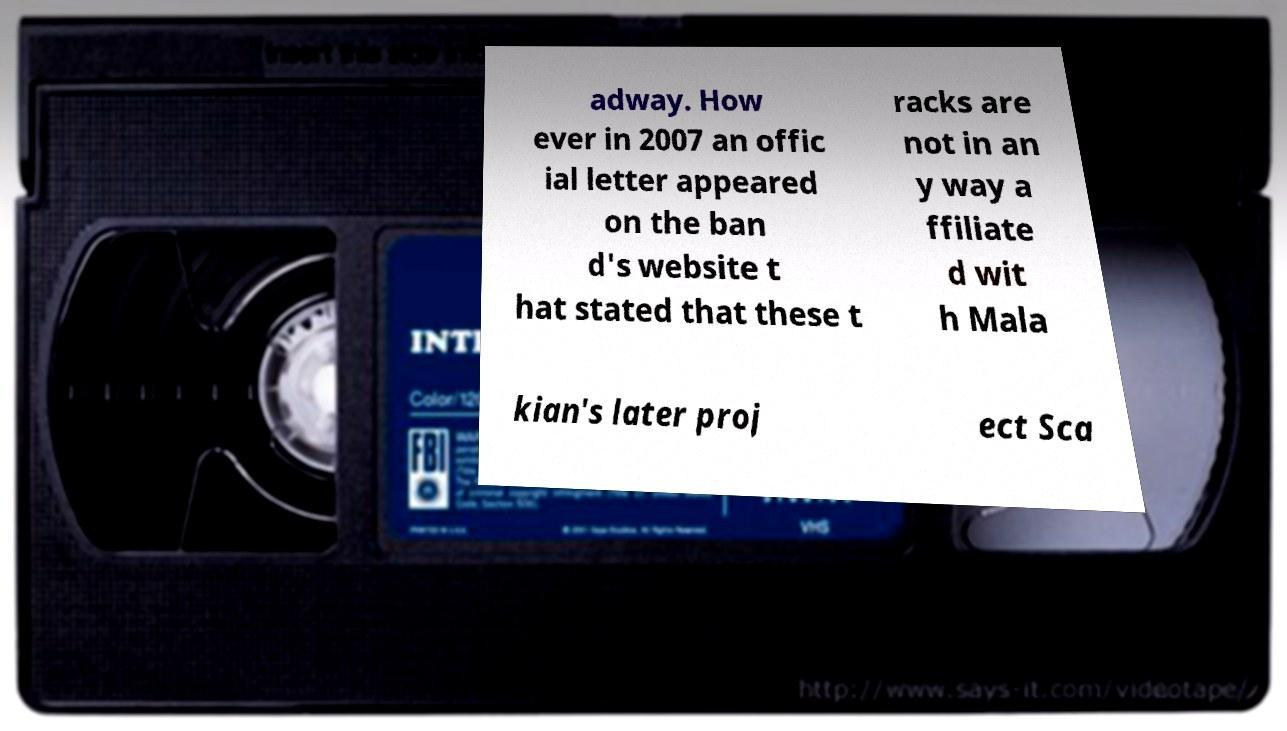Can you read and provide the text displayed in the image?This photo seems to have some interesting text. Can you extract and type it out for me? adway. How ever in 2007 an offic ial letter appeared on the ban d's website t hat stated that these t racks are not in an y way a ffiliate d wit h Mala kian's later proj ect Sca 